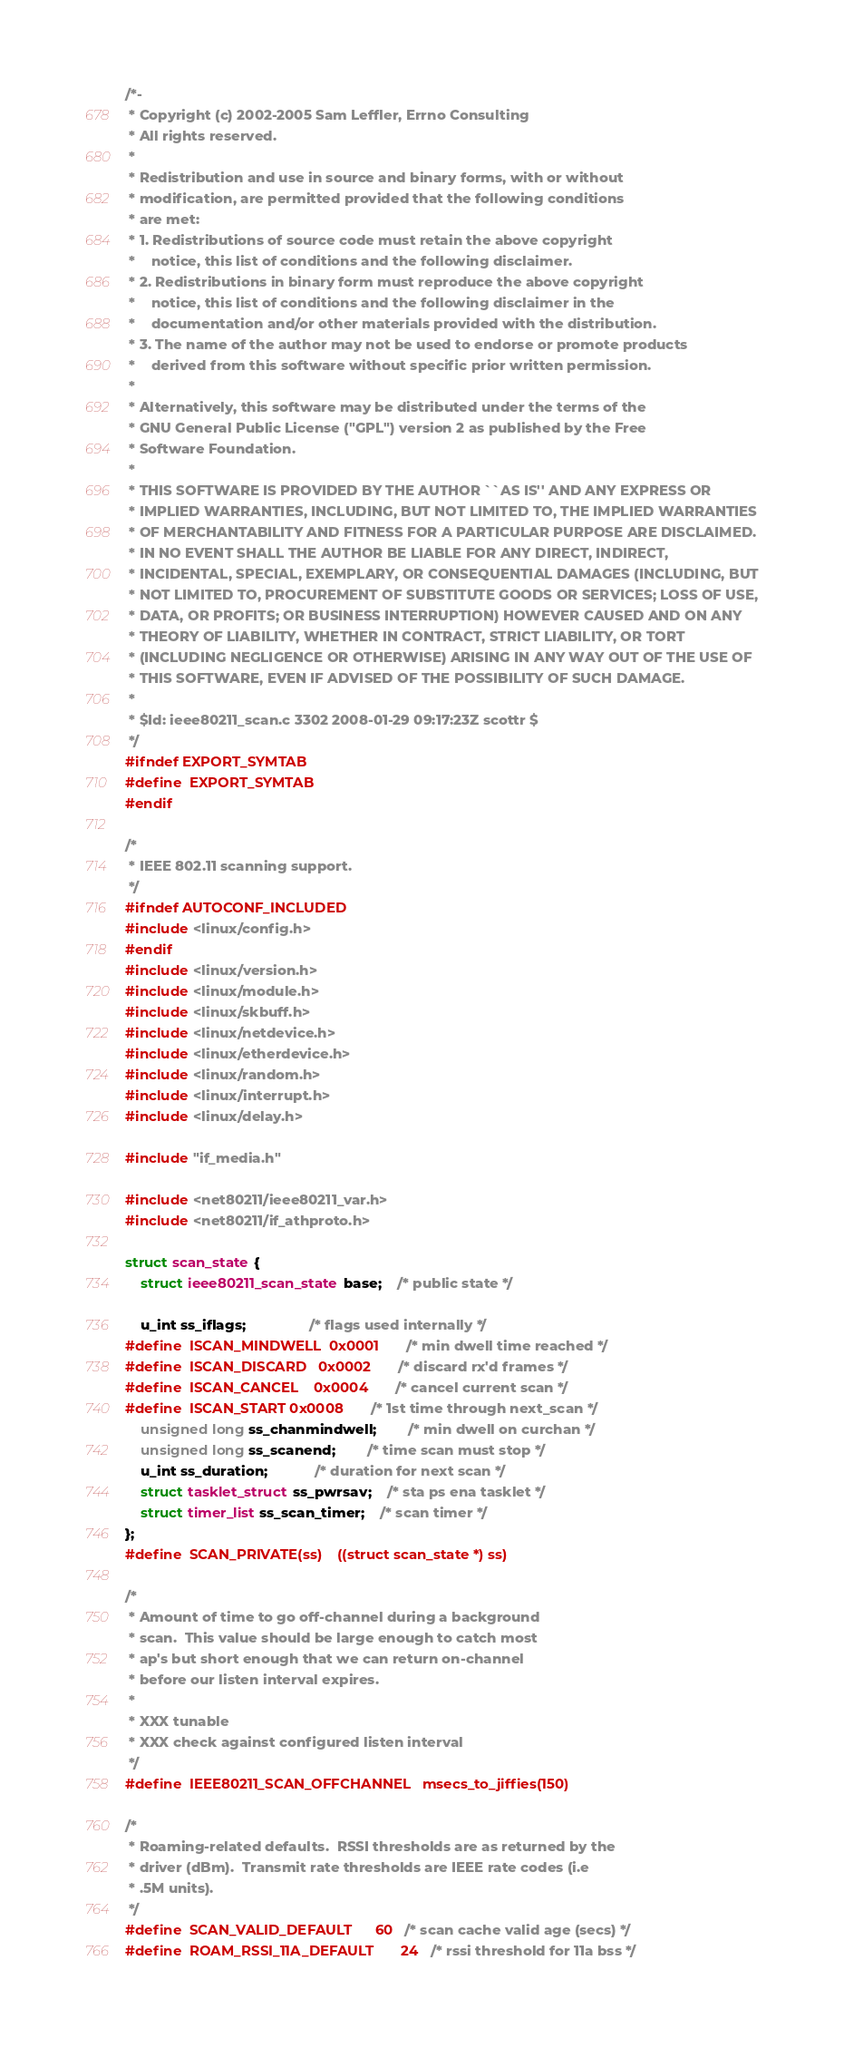<code> <loc_0><loc_0><loc_500><loc_500><_C_>/*-
 * Copyright (c) 2002-2005 Sam Leffler, Errno Consulting
 * All rights reserved.
 *
 * Redistribution and use in source and binary forms, with or without
 * modification, are permitted provided that the following conditions
 * are met:
 * 1. Redistributions of source code must retain the above copyright
 *    notice, this list of conditions and the following disclaimer.
 * 2. Redistributions in binary form must reproduce the above copyright
 *    notice, this list of conditions and the following disclaimer in the
 *    documentation and/or other materials provided with the distribution.
 * 3. The name of the author may not be used to endorse or promote products
 *    derived from this software without specific prior written permission.
 *
 * Alternatively, this software may be distributed under the terms of the
 * GNU General Public License ("GPL") version 2 as published by the Free
 * Software Foundation.
 *
 * THIS SOFTWARE IS PROVIDED BY THE AUTHOR ``AS IS'' AND ANY EXPRESS OR
 * IMPLIED WARRANTIES, INCLUDING, BUT NOT LIMITED TO, THE IMPLIED WARRANTIES
 * OF MERCHANTABILITY AND FITNESS FOR A PARTICULAR PURPOSE ARE DISCLAIMED.
 * IN NO EVENT SHALL THE AUTHOR BE LIABLE FOR ANY DIRECT, INDIRECT,
 * INCIDENTAL, SPECIAL, EXEMPLARY, OR CONSEQUENTIAL DAMAGES (INCLUDING, BUT
 * NOT LIMITED TO, PROCUREMENT OF SUBSTITUTE GOODS OR SERVICES; LOSS OF USE,
 * DATA, OR PROFITS; OR BUSINESS INTERRUPTION) HOWEVER CAUSED AND ON ANY
 * THEORY OF LIABILITY, WHETHER IN CONTRACT, STRICT LIABILITY, OR TORT
 * (INCLUDING NEGLIGENCE OR OTHERWISE) ARISING IN ANY WAY OUT OF THE USE OF
 * THIS SOFTWARE, EVEN IF ADVISED OF THE POSSIBILITY OF SUCH DAMAGE.
 *
 * $Id: ieee80211_scan.c 3302 2008-01-29 09:17:23Z scottr $
 */
#ifndef EXPORT_SYMTAB
#define	EXPORT_SYMTAB
#endif

/*
 * IEEE 802.11 scanning support.
 */
#ifndef AUTOCONF_INCLUDED
#include <linux/config.h>
#endif
#include <linux/version.h>
#include <linux/module.h>
#include <linux/skbuff.h>
#include <linux/netdevice.h>
#include <linux/etherdevice.h>
#include <linux/random.h>
#include <linux/interrupt.h>
#include <linux/delay.h>

#include "if_media.h"

#include <net80211/ieee80211_var.h>
#include <net80211/if_athproto.h>

struct scan_state {
	struct ieee80211_scan_state base;	/* public state */

	u_int ss_iflags;				/* flags used internally */
#define	ISCAN_MINDWELL 	0x0001		/* min dwell time reached */
#define	ISCAN_DISCARD	0x0002		/* discard rx'd frames */
#define	ISCAN_CANCEL	0x0004		/* cancel current scan */
#define	ISCAN_START	0x0008		/* 1st time through next_scan */
	unsigned long ss_chanmindwell;		/* min dwell on curchan */
	unsigned long ss_scanend;		/* time scan must stop */
	u_int ss_duration;			/* duration for next scan */
	struct tasklet_struct ss_pwrsav;	/* sta ps ena tasklet */
	struct timer_list ss_scan_timer;	/* scan timer */
};
#define	SCAN_PRIVATE(ss)	((struct scan_state *) ss)

/*
 * Amount of time to go off-channel during a background
 * scan.  This value should be large enough to catch most
 * ap's but short enough that we can return on-channel
 * before our listen interval expires.
 *
 * XXX tunable
 * XXX check against configured listen interval
 */
#define	IEEE80211_SCAN_OFFCHANNEL	msecs_to_jiffies(150)

/*
 * Roaming-related defaults.  RSSI thresholds are as returned by the
 * driver (dBm).  Transmit rate thresholds are IEEE rate codes (i.e
 * .5M units).
 */
#define	SCAN_VALID_DEFAULT		60	/* scan cache valid age (secs) */
#define	ROAM_RSSI_11A_DEFAULT		24	/* rssi threshold for 11a bss */</code> 